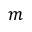Convert formula to latex. <formula><loc_0><loc_0><loc_500><loc_500>m</formula> 